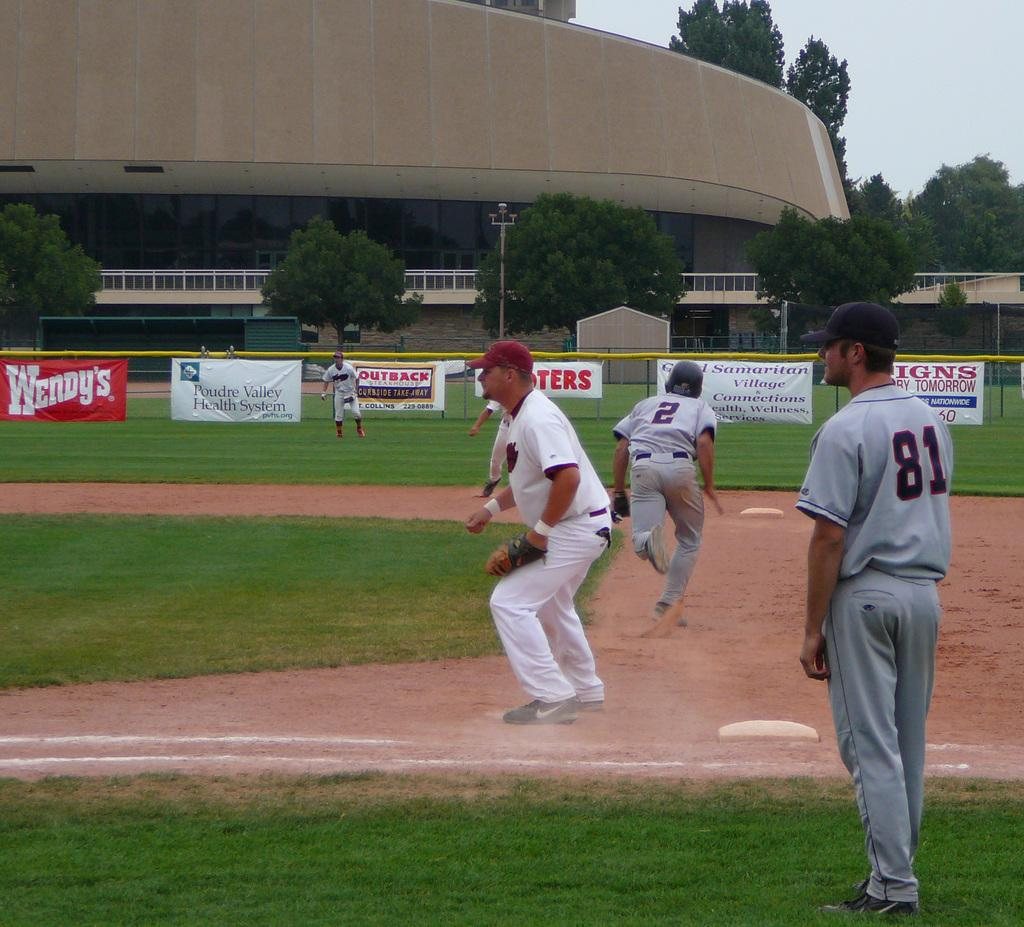<image>
Render a clear and concise summary of the photo. A baseball player wearing the number 2 jersey is running to second base. 